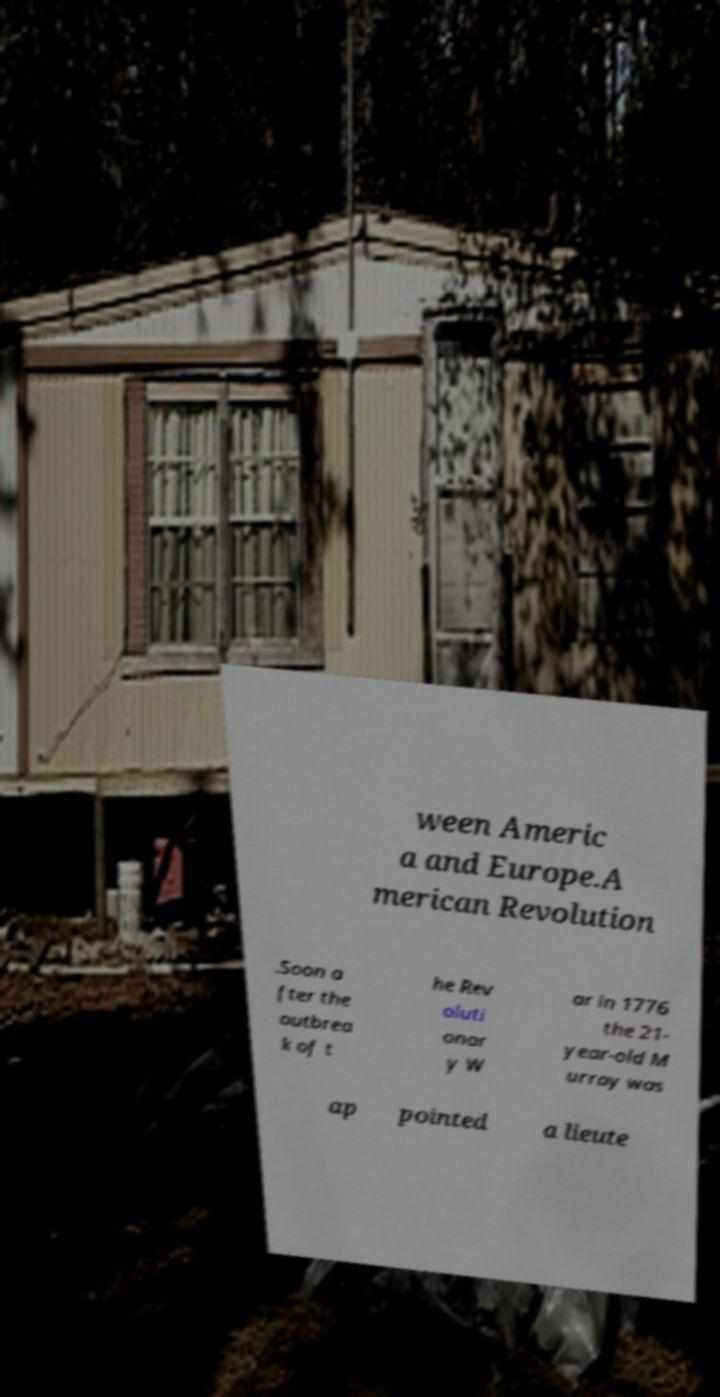For documentation purposes, I need the text within this image transcribed. Could you provide that? ween Americ a and Europe.A merican Revolution .Soon a fter the outbrea k of t he Rev oluti onar y W ar in 1776 the 21- year-old M urray was ap pointed a lieute 